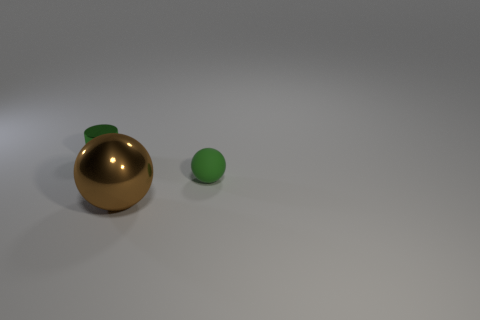Add 1 rubber balls. How many objects exist? 4 Subtract all balls. How many objects are left? 1 Subtract all big gray metallic cylinders. Subtract all big brown metal spheres. How many objects are left? 2 Add 2 small green metallic objects. How many small green metallic objects are left? 3 Add 3 green matte balls. How many green matte balls exist? 4 Subtract 0 blue cylinders. How many objects are left? 3 